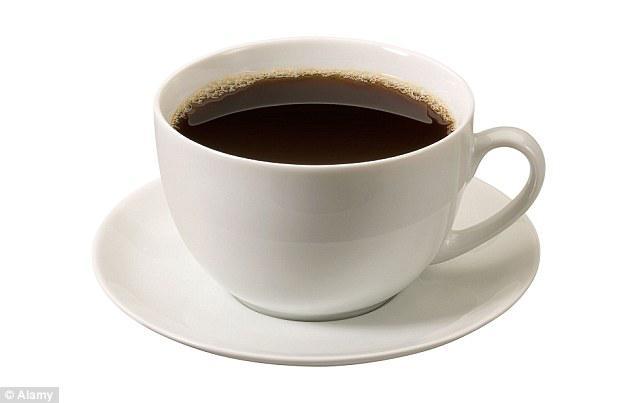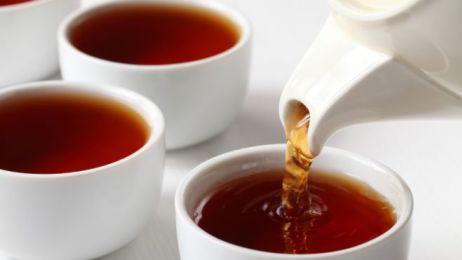The first image is the image on the left, the second image is the image on the right. For the images displayed, is the sentence "In one image, a liquid is being poured into a white cup from a white tea kettle" factually correct? Answer yes or no. Yes. The first image is the image on the left, the second image is the image on the right. Considering the images on both sides, is "A white teapot is pouring tea into a cup in one of the images." valid? Answer yes or no. Yes. 